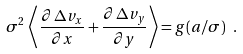<formula> <loc_0><loc_0><loc_500><loc_500>\sigma ^ { 2 } \, \left < \frac { \partial \, \Delta v _ { x } } { \partial x } + \frac { \partial \, \Delta v _ { y } } { \partial y } \right > = g ( a / \sigma ) \ .</formula> 